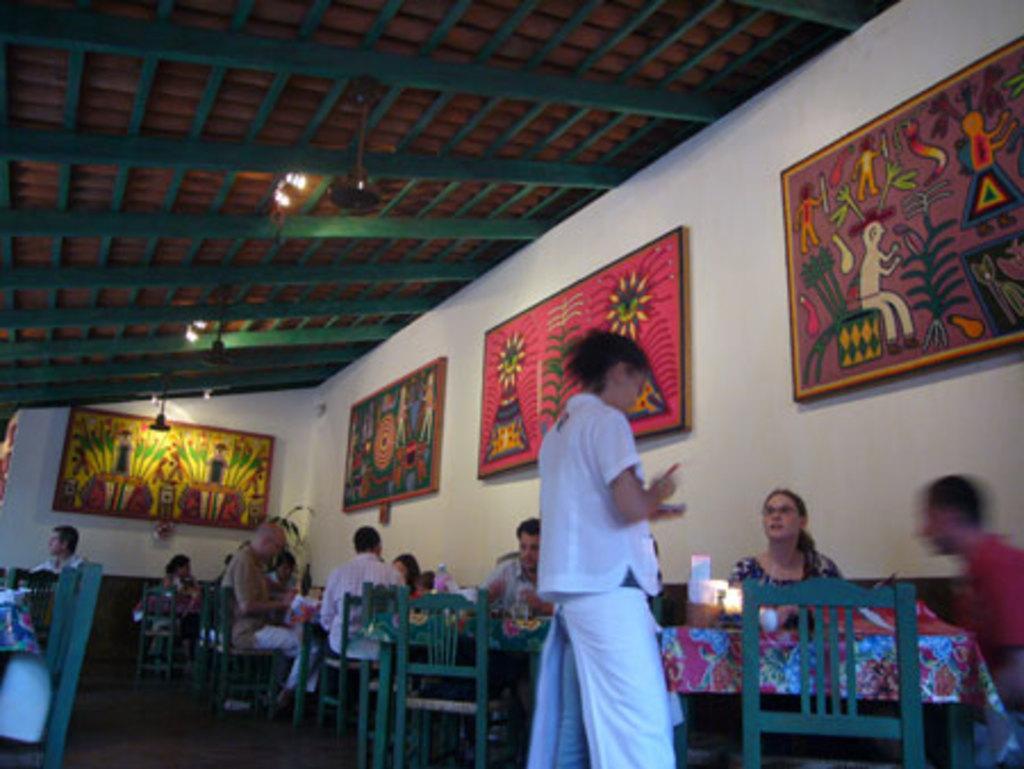Could you give a brief overview of what you see in this image? In this picture there is a woman who is wearing white dress. He is standing near to the table. On the table we can see water, glass and other objects. Here we can see two person sitting on the chair. On the wall we can see paintings. On the top we can see wooden roof and light. Here we can see group of persons who are sitting on the chair and eating the food. 